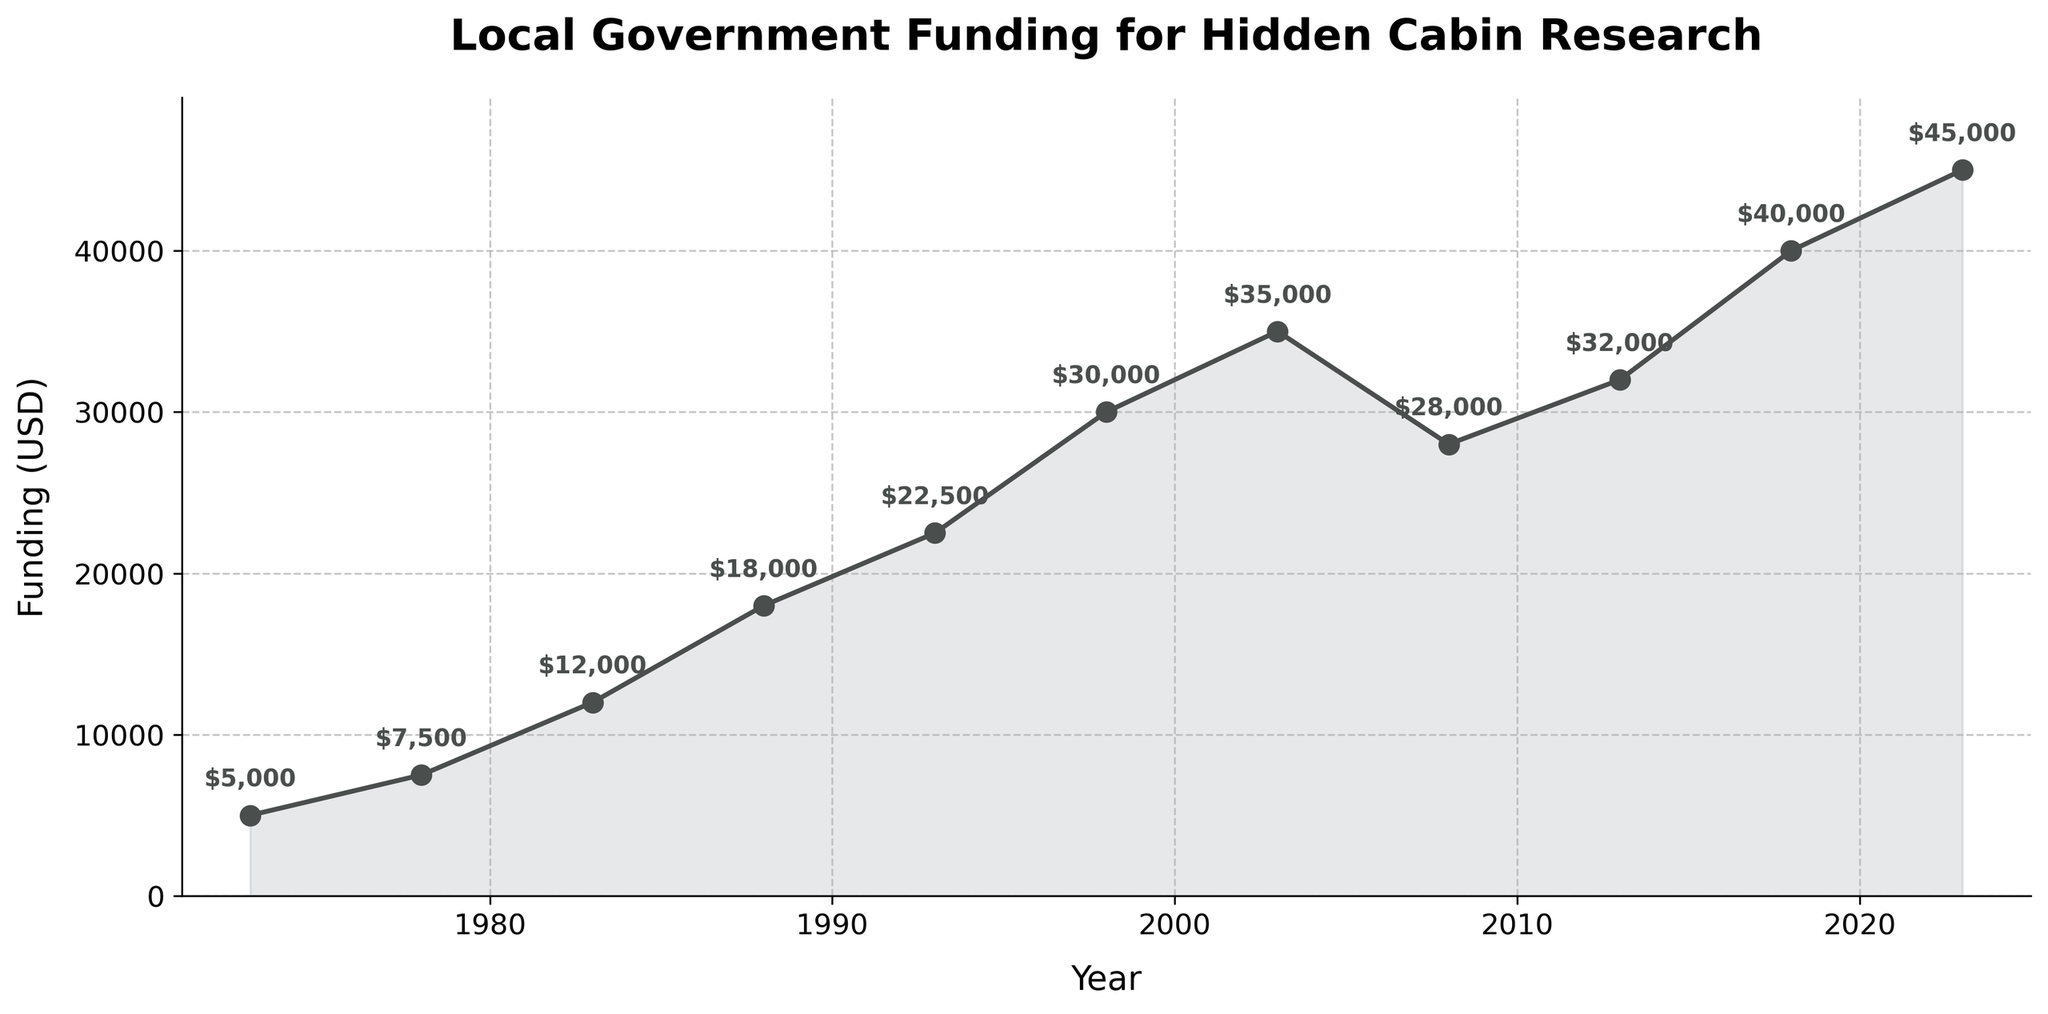When did the funding reach its highest point? Look for the year with the highest funding amount on the y-axis. The highest funding of $45,000 is reached in the year 2023.
Answer: 2023 During which year did the funding increase the most between two consecutive data points? Calculate the differences in funding between consecutive data points and determine which difference is the largest. The largest increase is from $18,000 in 1988 to $22,500 in 1993, a difference of $4,500.
Answer: 1988 to 1993 What's the average funding amount over the 50-year period? Add together all the funding amounts, then divide by the number of data points (10). The sum of the funding is $5000 + $7500 + $12000 + $18000 + $22500 + $30000 + $35000 + $28000 + $32000 + $40000 + $45000 which equals $280,000. The average is $280,000/11 which equals approximately $25,455.
Answer: $25,455 How many times did the funding decrease compared to the previous period? Observe the graph and count the number of times the line drops from one point to the next. The funding decreases once, from $35,000 in 2003 to $28,000 in 2008.
Answer: 1 Which year had the smallest funding and what was the amount? Identify the lowest point on the graph. The lowest funding amount is $5,000 in the year 1973.
Answer: 1973, $5,000 What is the difference in funding between the highest and the lowest years? Subtract the lowest funding amount from the highest funding amount. The highest funding is $45,000 in 2023 and the lowest is $5,000 in 1973. The difference is $45,000 - $5,000 which equals $40,000.
Answer: $40,000 How does the overall trend of funding change over the 50 years? Look at the general direction of the line on the graph. Despite the fluctuations, there is a clear upward trend in funding over the 50-year period.
Answer: Upward trend What was the funding amount in the year 1998? Look at the data point for the year 1998 on the graph and note the funding amount. The funding amount for 1998 is $30,000.
Answer: $30,000 Compare the funding amount in 2008 to 2018. Which year had higher funding and by how much? Examine the funding amounts for 2008 and 2018 and subtract the smaller amount from the larger amount. The funding in 2008 was $28,000 and in 2018 it was $40,000. The difference is $40,000 - $28,000 which equals $12,000.
Answer: 2018, $12,000 higher 